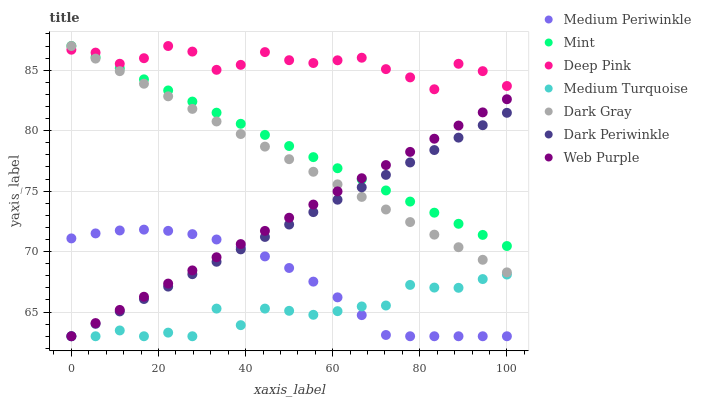Does Medium Turquoise have the minimum area under the curve?
Answer yes or no. Yes. Does Deep Pink have the maximum area under the curve?
Answer yes or no. Yes. Does Medium Periwinkle have the minimum area under the curve?
Answer yes or no. No. Does Medium Periwinkle have the maximum area under the curve?
Answer yes or no. No. Is Dark Gray the smoothest?
Answer yes or no. Yes. Is Medium Turquoise the roughest?
Answer yes or no. Yes. Is Medium Periwinkle the smoothest?
Answer yes or no. No. Is Medium Periwinkle the roughest?
Answer yes or no. No. Does Medium Periwinkle have the lowest value?
Answer yes or no. Yes. Does Dark Gray have the lowest value?
Answer yes or no. No. Does Mint have the highest value?
Answer yes or no. Yes. Does Medium Periwinkle have the highest value?
Answer yes or no. No. Is Web Purple less than Deep Pink?
Answer yes or no. Yes. Is Deep Pink greater than Dark Periwinkle?
Answer yes or no. Yes. Does Mint intersect Web Purple?
Answer yes or no. Yes. Is Mint less than Web Purple?
Answer yes or no. No. Is Mint greater than Web Purple?
Answer yes or no. No. Does Web Purple intersect Deep Pink?
Answer yes or no. No. 